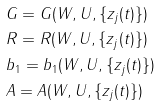<formula> <loc_0><loc_0><loc_500><loc_500>& G = G ( W , U , \{ z _ { j } ( t ) \} ) \\ & R = R ( W , U , \{ z _ { j } ( t ) \} ) \\ & b _ { 1 } = b _ { 1 } ( W , U , \{ z _ { j } ( t ) \} ) \\ & A = A ( W , U , \{ z _ { j } ( t ) \} )</formula> 